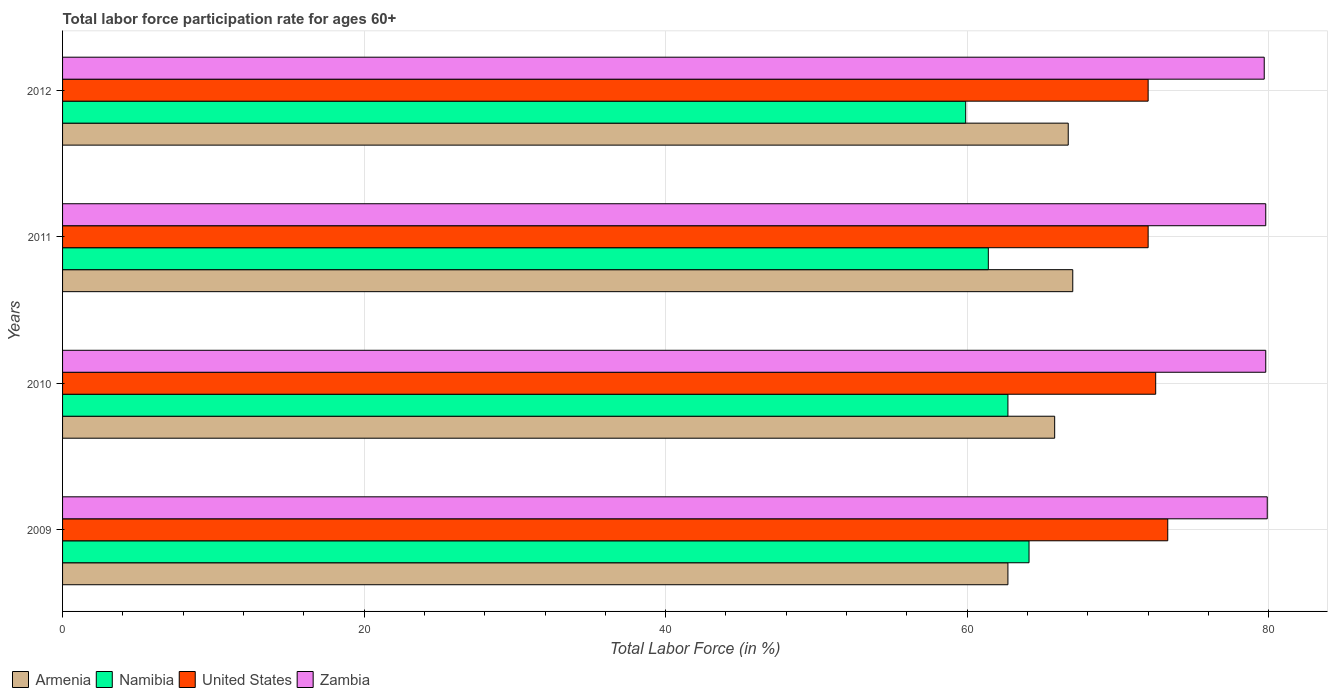How many groups of bars are there?
Ensure brevity in your answer.  4. How many bars are there on the 2nd tick from the bottom?
Offer a terse response. 4. What is the label of the 1st group of bars from the top?
Make the answer very short. 2012. What is the labor force participation rate in Zambia in 2011?
Your answer should be compact. 79.8. Across all years, what is the maximum labor force participation rate in United States?
Your response must be concise. 73.3. Across all years, what is the minimum labor force participation rate in Namibia?
Your response must be concise. 59.9. In which year was the labor force participation rate in Armenia maximum?
Provide a succinct answer. 2011. In which year was the labor force participation rate in Zambia minimum?
Make the answer very short. 2012. What is the total labor force participation rate in Namibia in the graph?
Your answer should be very brief. 248.1. What is the difference between the labor force participation rate in United States in 2010 and that in 2011?
Give a very brief answer. 0.5. What is the difference between the labor force participation rate in Namibia in 2011 and the labor force participation rate in Armenia in 2012?
Give a very brief answer. -5.3. What is the average labor force participation rate in Zambia per year?
Your answer should be compact. 79.8. In the year 2010, what is the difference between the labor force participation rate in United States and labor force participation rate in Armenia?
Provide a succinct answer. 6.7. What is the ratio of the labor force participation rate in United States in 2009 to that in 2012?
Your answer should be compact. 1.02. Is the labor force participation rate in Namibia in 2010 less than that in 2012?
Give a very brief answer. No. What is the difference between the highest and the second highest labor force participation rate in Zambia?
Make the answer very short. 0.1. What is the difference between the highest and the lowest labor force participation rate in Zambia?
Provide a short and direct response. 0.2. Is it the case that in every year, the sum of the labor force participation rate in Zambia and labor force participation rate in Namibia is greater than the sum of labor force participation rate in United States and labor force participation rate in Armenia?
Make the answer very short. Yes. What does the 4th bar from the top in 2011 represents?
Keep it short and to the point. Armenia. Are all the bars in the graph horizontal?
Make the answer very short. Yes. What is the difference between two consecutive major ticks on the X-axis?
Your answer should be compact. 20. Does the graph contain grids?
Provide a short and direct response. Yes. Where does the legend appear in the graph?
Your answer should be very brief. Bottom left. How many legend labels are there?
Offer a terse response. 4. How are the legend labels stacked?
Keep it short and to the point. Horizontal. What is the title of the graph?
Offer a terse response. Total labor force participation rate for ages 60+. Does "Brunei Darussalam" appear as one of the legend labels in the graph?
Your answer should be very brief. No. What is the label or title of the Y-axis?
Keep it short and to the point. Years. What is the Total Labor Force (in %) in Armenia in 2009?
Ensure brevity in your answer.  62.7. What is the Total Labor Force (in %) in Namibia in 2009?
Make the answer very short. 64.1. What is the Total Labor Force (in %) in United States in 2009?
Ensure brevity in your answer.  73.3. What is the Total Labor Force (in %) in Zambia in 2009?
Your answer should be compact. 79.9. What is the Total Labor Force (in %) of Armenia in 2010?
Your answer should be very brief. 65.8. What is the Total Labor Force (in %) in Namibia in 2010?
Your answer should be compact. 62.7. What is the Total Labor Force (in %) in United States in 2010?
Provide a short and direct response. 72.5. What is the Total Labor Force (in %) in Zambia in 2010?
Your answer should be compact. 79.8. What is the Total Labor Force (in %) of Armenia in 2011?
Your response must be concise. 67. What is the Total Labor Force (in %) in Namibia in 2011?
Keep it short and to the point. 61.4. What is the Total Labor Force (in %) in United States in 2011?
Keep it short and to the point. 72. What is the Total Labor Force (in %) of Zambia in 2011?
Make the answer very short. 79.8. What is the Total Labor Force (in %) of Armenia in 2012?
Ensure brevity in your answer.  66.7. What is the Total Labor Force (in %) of Namibia in 2012?
Ensure brevity in your answer.  59.9. What is the Total Labor Force (in %) in United States in 2012?
Give a very brief answer. 72. What is the Total Labor Force (in %) of Zambia in 2012?
Your answer should be very brief. 79.7. Across all years, what is the maximum Total Labor Force (in %) of Armenia?
Give a very brief answer. 67. Across all years, what is the maximum Total Labor Force (in %) in Namibia?
Provide a succinct answer. 64.1. Across all years, what is the maximum Total Labor Force (in %) in United States?
Make the answer very short. 73.3. Across all years, what is the maximum Total Labor Force (in %) of Zambia?
Keep it short and to the point. 79.9. Across all years, what is the minimum Total Labor Force (in %) of Armenia?
Your answer should be very brief. 62.7. Across all years, what is the minimum Total Labor Force (in %) of Namibia?
Provide a short and direct response. 59.9. Across all years, what is the minimum Total Labor Force (in %) in Zambia?
Provide a short and direct response. 79.7. What is the total Total Labor Force (in %) of Armenia in the graph?
Provide a succinct answer. 262.2. What is the total Total Labor Force (in %) in Namibia in the graph?
Make the answer very short. 248.1. What is the total Total Labor Force (in %) of United States in the graph?
Offer a terse response. 289.8. What is the total Total Labor Force (in %) in Zambia in the graph?
Offer a terse response. 319.2. What is the difference between the Total Labor Force (in %) in United States in 2009 and that in 2010?
Provide a short and direct response. 0.8. What is the difference between the Total Labor Force (in %) in Namibia in 2009 and that in 2011?
Offer a very short reply. 2.7. What is the difference between the Total Labor Force (in %) of United States in 2009 and that in 2011?
Ensure brevity in your answer.  1.3. What is the difference between the Total Labor Force (in %) of Armenia in 2009 and that in 2012?
Provide a succinct answer. -4. What is the difference between the Total Labor Force (in %) of Namibia in 2009 and that in 2012?
Provide a succinct answer. 4.2. What is the difference between the Total Labor Force (in %) of United States in 2009 and that in 2012?
Provide a succinct answer. 1.3. What is the difference between the Total Labor Force (in %) of United States in 2010 and that in 2011?
Ensure brevity in your answer.  0.5. What is the difference between the Total Labor Force (in %) of Zambia in 2010 and that in 2011?
Make the answer very short. 0. What is the difference between the Total Labor Force (in %) of Armenia in 2010 and that in 2012?
Offer a terse response. -0.9. What is the difference between the Total Labor Force (in %) of Namibia in 2010 and that in 2012?
Give a very brief answer. 2.8. What is the difference between the Total Labor Force (in %) of Zambia in 2010 and that in 2012?
Offer a very short reply. 0.1. What is the difference between the Total Labor Force (in %) of Namibia in 2011 and that in 2012?
Your answer should be very brief. 1.5. What is the difference between the Total Labor Force (in %) in Armenia in 2009 and the Total Labor Force (in %) in United States in 2010?
Your answer should be compact. -9.8. What is the difference between the Total Labor Force (in %) in Armenia in 2009 and the Total Labor Force (in %) in Zambia in 2010?
Keep it short and to the point. -17.1. What is the difference between the Total Labor Force (in %) in Namibia in 2009 and the Total Labor Force (in %) in Zambia in 2010?
Offer a terse response. -15.7. What is the difference between the Total Labor Force (in %) in Armenia in 2009 and the Total Labor Force (in %) in Namibia in 2011?
Make the answer very short. 1.3. What is the difference between the Total Labor Force (in %) in Armenia in 2009 and the Total Labor Force (in %) in United States in 2011?
Provide a short and direct response. -9.3. What is the difference between the Total Labor Force (in %) in Armenia in 2009 and the Total Labor Force (in %) in Zambia in 2011?
Your answer should be compact. -17.1. What is the difference between the Total Labor Force (in %) in Namibia in 2009 and the Total Labor Force (in %) in United States in 2011?
Make the answer very short. -7.9. What is the difference between the Total Labor Force (in %) in Namibia in 2009 and the Total Labor Force (in %) in Zambia in 2011?
Provide a succinct answer. -15.7. What is the difference between the Total Labor Force (in %) in United States in 2009 and the Total Labor Force (in %) in Zambia in 2011?
Your answer should be compact. -6.5. What is the difference between the Total Labor Force (in %) of Armenia in 2009 and the Total Labor Force (in %) of Namibia in 2012?
Ensure brevity in your answer.  2.8. What is the difference between the Total Labor Force (in %) of Armenia in 2009 and the Total Labor Force (in %) of United States in 2012?
Give a very brief answer. -9.3. What is the difference between the Total Labor Force (in %) of Namibia in 2009 and the Total Labor Force (in %) of Zambia in 2012?
Give a very brief answer. -15.6. What is the difference between the Total Labor Force (in %) in Armenia in 2010 and the Total Labor Force (in %) in Namibia in 2011?
Your answer should be compact. 4.4. What is the difference between the Total Labor Force (in %) in Armenia in 2010 and the Total Labor Force (in %) in Zambia in 2011?
Keep it short and to the point. -14. What is the difference between the Total Labor Force (in %) of Namibia in 2010 and the Total Labor Force (in %) of United States in 2011?
Your answer should be very brief. -9.3. What is the difference between the Total Labor Force (in %) in Namibia in 2010 and the Total Labor Force (in %) in Zambia in 2011?
Your answer should be compact. -17.1. What is the difference between the Total Labor Force (in %) of United States in 2010 and the Total Labor Force (in %) of Zambia in 2011?
Make the answer very short. -7.3. What is the difference between the Total Labor Force (in %) of Armenia in 2010 and the Total Labor Force (in %) of United States in 2012?
Provide a short and direct response. -6.2. What is the difference between the Total Labor Force (in %) of Namibia in 2010 and the Total Labor Force (in %) of United States in 2012?
Keep it short and to the point. -9.3. What is the difference between the Total Labor Force (in %) in United States in 2010 and the Total Labor Force (in %) in Zambia in 2012?
Give a very brief answer. -7.2. What is the difference between the Total Labor Force (in %) of Armenia in 2011 and the Total Labor Force (in %) of Namibia in 2012?
Provide a succinct answer. 7.1. What is the difference between the Total Labor Force (in %) of Armenia in 2011 and the Total Labor Force (in %) of United States in 2012?
Your answer should be very brief. -5. What is the difference between the Total Labor Force (in %) of Namibia in 2011 and the Total Labor Force (in %) of Zambia in 2012?
Your answer should be very brief. -18.3. What is the difference between the Total Labor Force (in %) in United States in 2011 and the Total Labor Force (in %) in Zambia in 2012?
Make the answer very short. -7.7. What is the average Total Labor Force (in %) of Armenia per year?
Give a very brief answer. 65.55. What is the average Total Labor Force (in %) in Namibia per year?
Offer a terse response. 62.02. What is the average Total Labor Force (in %) in United States per year?
Keep it short and to the point. 72.45. What is the average Total Labor Force (in %) in Zambia per year?
Ensure brevity in your answer.  79.8. In the year 2009, what is the difference between the Total Labor Force (in %) in Armenia and Total Labor Force (in %) in Namibia?
Give a very brief answer. -1.4. In the year 2009, what is the difference between the Total Labor Force (in %) of Armenia and Total Labor Force (in %) of Zambia?
Your answer should be compact. -17.2. In the year 2009, what is the difference between the Total Labor Force (in %) of Namibia and Total Labor Force (in %) of Zambia?
Your response must be concise. -15.8. In the year 2009, what is the difference between the Total Labor Force (in %) in United States and Total Labor Force (in %) in Zambia?
Your response must be concise. -6.6. In the year 2010, what is the difference between the Total Labor Force (in %) of Armenia and Total Labor Force (in %) of United States?
Your response must be concise. -6.7. In the year 2010, what is the difference between the Total Labor Force (in %) in Namibia and Total Labor Force (in %) in United States?
Ensure brevity in your answer.  -9.8. In the year 2010, what is the difference between the Total Labor Force (in %) of Namibia and Total Labor Force (in %) of Zambia?
Provide a succinct answer. -17.1. In the year 2011, what is the difference between the Total Labor Force (in %) of Armenia and Total Labor Force (in %) of United States?
Provide a succinct answer. -5. In the year 2011, what is the difference between the Total Labor Force (in %) of Armenia and Total Labor Force (in %) of Zambia?
Provide a succinct answer. -12.8. In the year 2011, what is the difference between the Total Labor Force (in %) of Namibia and Total Labor Force (in %) of Zambia?
Offer a terse response. -18.4. In the year 2012, what is the difference between the Total Labor Force (in %) of Armenia and Total Labor Force (in %) of Zambia?
Your answer should be compact. -13. In the year 2012, what is the difference between the Total Labor Force (in %) in Namibia and Total Labor Force (in %) in United States?
Offer a very short reply. -12.1. In the year 2012, what is the difference between the Total Labor Force (in %) in Namibia and Total Labor Force (in %) in Zambia?
Provide a succinct answer. -19.8. In the year 2012, what is the difference between the Total Labor Force (in %) in United States and Total Labor Force (in %) in Zambia?
Provide a short and direct response. -7.7. What is the ratio of the Total Labor Force (in %) of Armenia in 2009 to that in 2010?
Make the answer very short. 0.95. What is the ratio of the Total Labor Force (in %) in Namibia in 2009 to that in 2010?
Provide a short and direct response. 1.02. What is the ratio of the Total Labor Force (in %) in Armenia in 2009 to that in 2011?
Keep it short and to the point. 0.94. What is the ratio of the Total Labor Force (in %) of Namibia in 2009 to that in 2011?
Your answer should be compact. 1.04. What is the ratio of the Total Labor Force (in %) in United States in 2009 to that in 2011?
Keep it short and to the point. 1.02. What is the ratio of the Total Labor Force (in %) of Namibia in 2009 to that in 2012?
Give a very brief answer. 1.07. What is the ratio of the Total Labor Force (in %) in United States in 2009 to that in 2012?
Your answer should be compact. 1.02. What is the ratio of the Total Labor Force (in %) of Zambia in 2009 to that in 2012?
Offer a very short reply. 1. What is the ratio of the Total Labor Force (in %) in Armenia in 2010 to that in 2011?
Your answer should be very brief. 0.98. What is the ratio of the Total Labor Force (in %) in Namibia in 2010 to that in 2011?
Your answer should be very brief. 1.02. What is the ratio of the Total Labor Force (in %) of United States in 2010 to that in 2011?
Give a very brief answer. 1.01. What is the ratio of the Total Labor Force (in %) in Armenia in 2010 to that in 2012?
Provide a succinct answer. 0.99. What is the ratio of the Total Labor Force (in %) of Namibia in 2010 to that in 2012?
Offer a very short reply. 1.05. What is the ratio of the Total Labor Force (in %) of Zambia in 2010 to that in 2012?
Give a very brief answer. 1. What is the ratio of the Total Labor Force (in %) in Armenia in 2011 to that in 2012?
Your answer should be compact. 1. What is the ratio of the Total Labor Force (in %) in Namibia in 2011 to that in 2012?
Provide a succinct answer. 1.02. What is the ratio of the Total Labor Force (in %) of United States in 2011 to that in 2012?
Your response must be concise. 1. What is the difference between the highest and the second highest Total Labor Force (in %) of Armenia?
Keep it short and to the point. 0.3. What is the difference between the highest and the second highest Total Labor Force (in %) in United States?
Provide a succinct answer. 0.8. What is the difference between the highest and the lowest Total Labor Force (in %) of Armenia?
Offer a terse response. 4.3. What is the difference between the highest and the lowest Total Labor Force (in %) of Namibia?
Give a very brief answer. 4.2. What is the difference between the highest and the lowest Total Labor Force (in %) in United States?
Offer a very short reply. 1.3. 